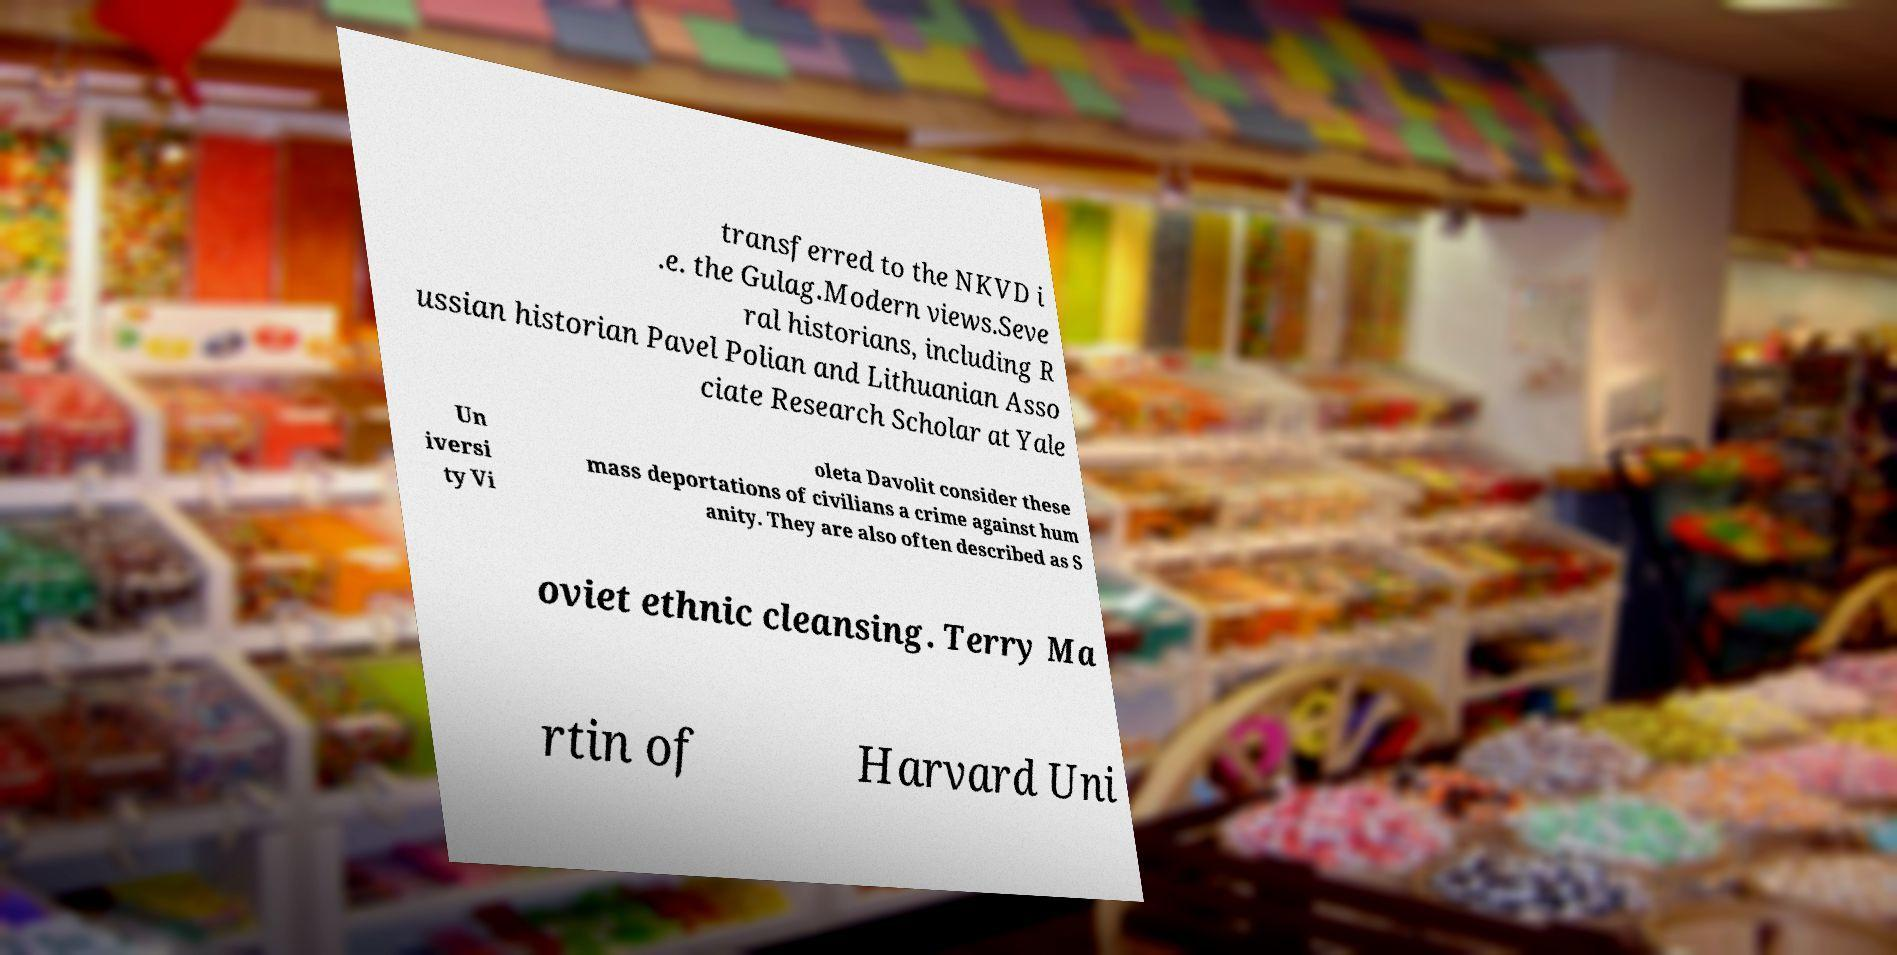What messages or text are displayed in this image? I need them in a readable, typed format. transferred to the NKVD i .e. the Gulag.Modern views.Seve ral historians, including R ussian historian Pavel Polian and Lithuanian Asso ciate Research Scholar at Yale Un iversi ty Vi oleta Davolit consider these mass deportations of civilians a crime against hum anity. They are also often described as S oviet ethnic cleansing. Terry Ma rtin of Harvard Uni 